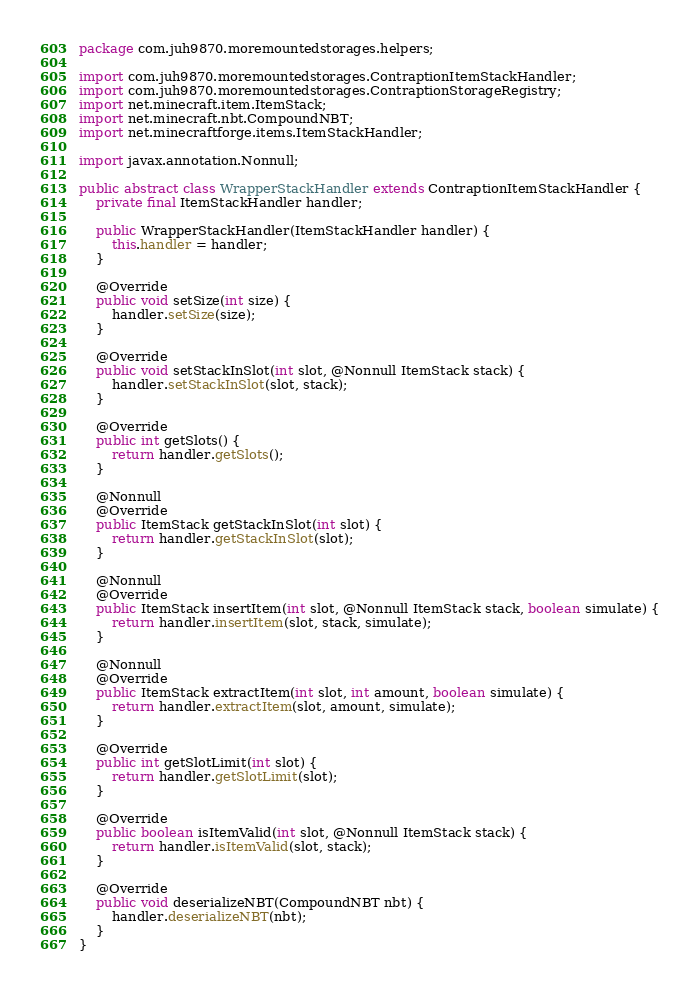Convert code to text. <code><loc_0><loc_0><loc_500><loc_500><_Java_>package com.juh9870.moremountedstorages.helpers;

import com.juh9870.moremountedstorages.ContraptionItemStackHandler;
import com.juh9870.moremountedstorages.ContraptionStorageRegistry;
import net.minecraft.item.ItemStack;
import net.minecraft.nbt.CompoundNBT;
import net.minecraftforge.items.ItemStackHandler;

import javax.annotation.Nonnull;

public abstract class WrapperStackHandler extends ContraptionItemStackHandler {
	private final ItemStackHandler handler;

	public WrapperStackHandler(ItemStackHandler handler) {
		this.handler = handler;
	}

	@Override
	public void setSize(int size) {
		handler.setSize(size);
	}

	@Override
	public void setStackInSlot(int slot, @Nonnull ItemStack stack) {
		handler.setStackInSlot(slot, stack);
	}

	@Override
	public int getSlots() {
		return handler.getSlots();
	}

	@Nonnull
	@Override
	public ItemStack getStackInSlot(int slot) {
		return handler.getStackInSlot(slot);
	}

	@Nonnull
	@Override
	public ItemStack insertItem(int slot, @Nonnull ItemStack stack, boolean simulate) {
		return handler.insertItem(slot, stack, simulate);
	}

	@Nonnull
	@Override
	public ItemStack extractItem(int slot, int amount, boolean simulate) {
		return handler.extractItem(slot, amount, simulate);
	}

	@Override
	public int getSlotLimit(int slot) {
		return handler.getSlotLimit(slot);
	}

	@Override
	public boolean isItemValid(int slot, @Nonnull ItemStack stack) {
		return handler.isItemValid(slot, stack);
	}

	@Override
	public void deserializeNBT(CompoundNBT nbt) {
		handler.deserializeNBT(nbt);
	}
}
</code> 